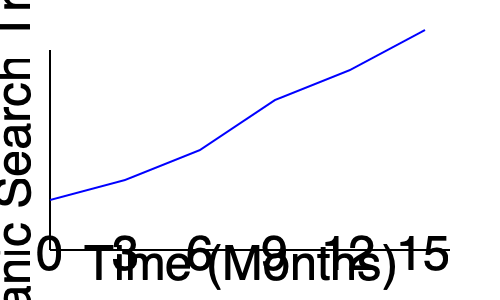Analyze the organic search traffic trend shown in the line graph for a medical clinic website over a 15-month period. What key SEO strategy should be recommended to maintain this positive trend? To answer this question, let's analyze the graph and consider effective SEO strategies for medical clinics:

1. Trend analysis: The graph shows a consistent upward trend in organic search traffic over 15 months, indicating successful SEO efforts.

2. Growth rate: The slope of the line increases over time, suggesting accelerating growth in organic traffic.

3. Medical clinic context: For medical websites, content quality and expertise are crucial ranking factors due to Google's E-A-T (Expertise, Authoritativeness, Trustworthiness) guidelines.

4. Long-term strategy: The steady growth over 15 months indicates a sustainable approach rather than short-term tactics.

5. Content strategy: Given the consistent growth and the importance of E-A-T for medical sites, a content strategy focusing on creating high-quality, expert-written content is likely driving this trend.

6. Recommendation: To maintain this positive trend, the key strategy should be to continue and expand the creation of authoritative, in-depth medical content written by healthcare professionals.

This approach aligns with Google's quality guidelines for medical sites, builds trust with users, and provides valuable information that can attract and engage potential patients.
Answer: Continue creating authoritative, expert-written medical content 